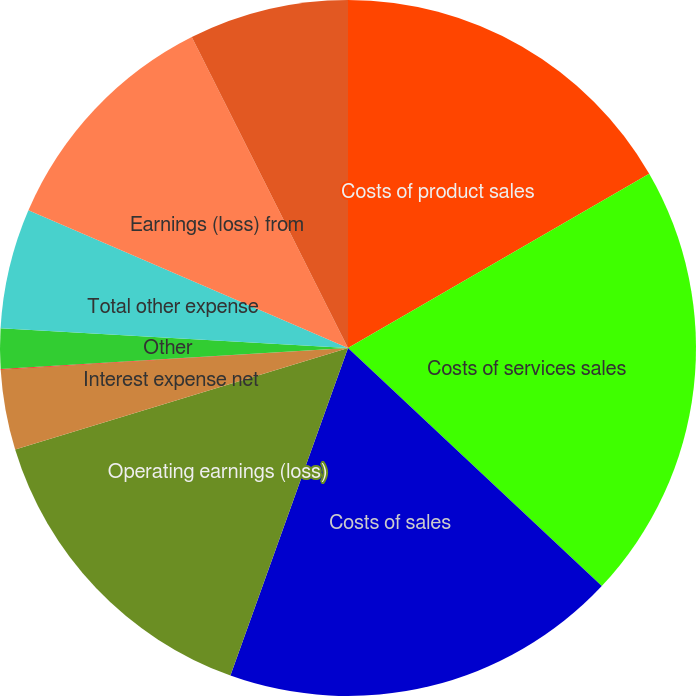<chart> <loc_0><loc_0><loc_500><loc_500><pie_chart><fcel>Costs of product sales<fcel>Costs of services sales<fcel>Costs of sales<fcel>Operating earnings (loss)<fcel>Interest expense net<fcel>Gains (losses) on sales of<fcel>Other<fcel>Total other expense<fcel>Earnings (loss) from<fcel>Income tax expense (benefit)<nl><fcel>16.65%<fcel>20.34%<fcel>18.49%<fcel>14.8%<fcel>3.72%<fcel>0.03%<fcel>1.87%<fcel>5.57%<fcel>11.11%<fcel>7.41%<nl></chart> 